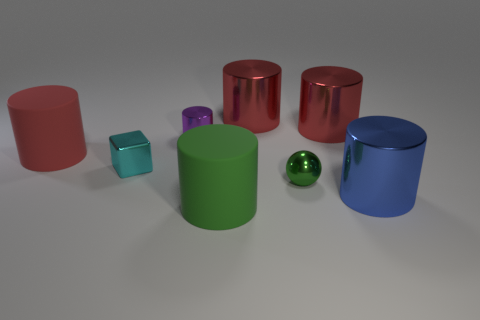How would you categorize the objects by color, and what does that tell us about the variety present? The objects consist of various colors including red, purple, green, and blue shades. This introduces a pleasant visual diversity to the scene, showcasing a spectrum from warm to cool colors that could reflect a deliberate design choice for visual appeal or organization. Could there be a specific reason for this arrangement of colors? One possibility is that the arrangement is purely aesthetic to make the scene vibrant and captivating. Another reason could be educational or functional, employing color-coding to categorize the objects or demonstrate color theory relationships. 